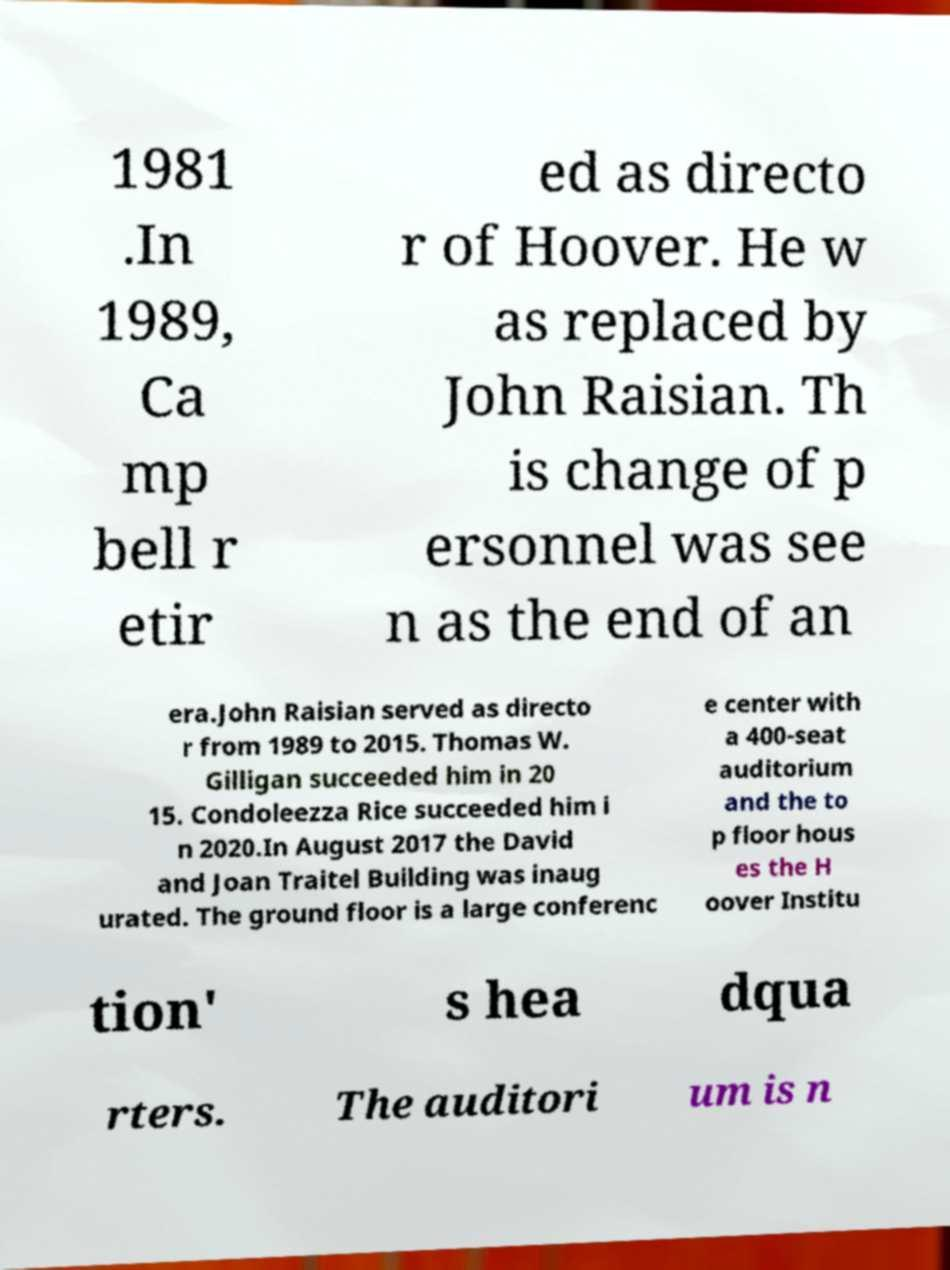Could you assist in decoding the text presented in this image and type it out clearly? 1981 .In 1989, Ca mp bell r etir ed as directo r of Hoover. He w as replaced by John Raisian. Th is change of p ersonnel was see n as the end of an era.John Raisian served as directo r from 1989 to 2015. Thomas W. Gilligan succeeded him in 20 15. Condoleezza Rice succeeded him i n 2020.In August 2017 the David and Joan Traitel Building was inaug urated. The ground floor is a large conferenc e center with a 400-seat auditorium and the to p floor hous es the H oover Institu tion' s hea dqua rters. The auditori um is n 